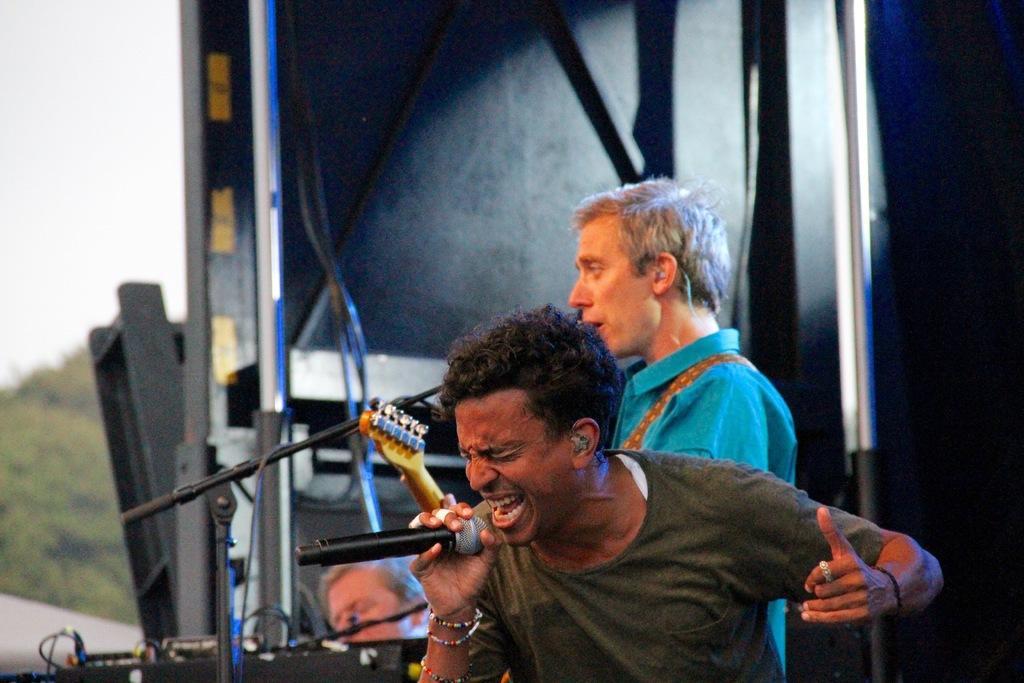What is the man in the image doing? The man is singing in the image. What is the man holding while singing? The man is holding a microphone. Can you describe the background of the image? In the background, there are two people, rods, wires, trees, the sky, and other objects visible. What type of butter can be seen melting on the ship in the image? There is no butter or ship present in the image. 